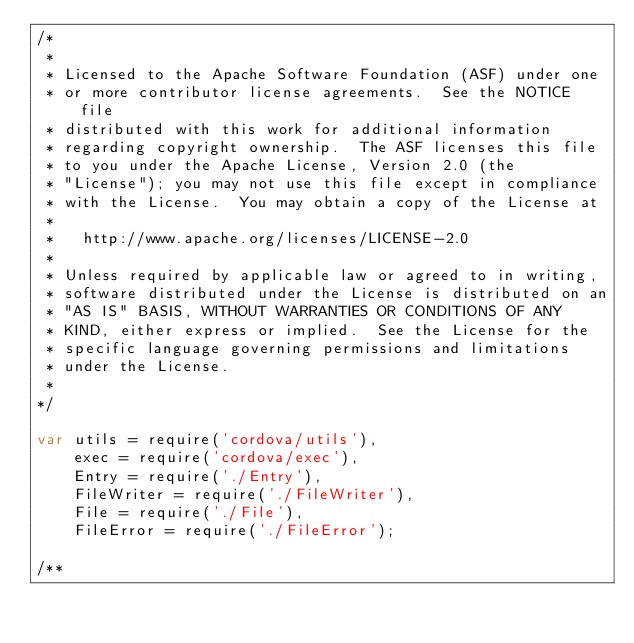Convert code to text. <code><loc_0><loc_0><loc_500><loc_500><_JavaScript_>/*
 *
 * Licensed to the Apache Software Foundation (ASF) under one
 * or more contributor license agreements.  See the NOTICE file
 * distributed with this work for additional information
 * regarding copyright ownership.  The ASF licenses this file
 * to you under the Apache License, Version 2.0 (the
 * "License"); you may not use this file except in compliance
 * with the License.  You may obtain a copy of the License at
 *
 *   http://www.apache.org/licenses/LICENSE-2.0
 *
 * Unless required by applicable law or agreed to in writing,
 * software distributed under the License is distributed on an
 * "AS IS" BASIS, WITHOUT WARRANTIES OR CONDITIONS OF ANY
 * KIND, either express or implied.  See the License for the
 * specific language governing permissions and limitations
 * under the License.
 *
*/

var utils = require('cordova/utils'),
    exec = require('cordova/exec'),
    Entry = require('./Entry'),
    FileWriter = require('./FileWriter'),
    File = require('./File'),
    FileError = require('./FileError');

/**</code> 